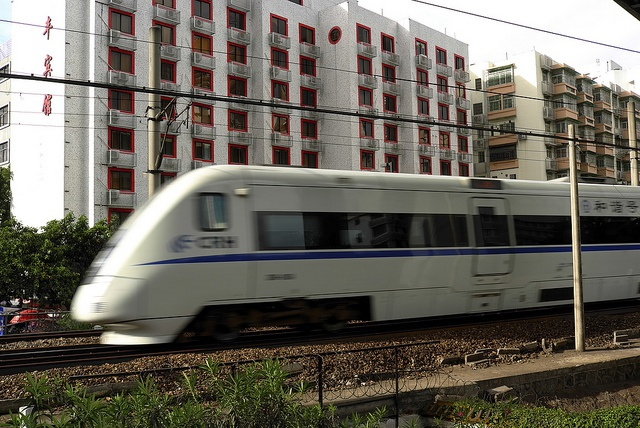Describe the objects in this image and their specific colors. I can see a train in white, gray, black, ivory, and darkgray tones in this image. 